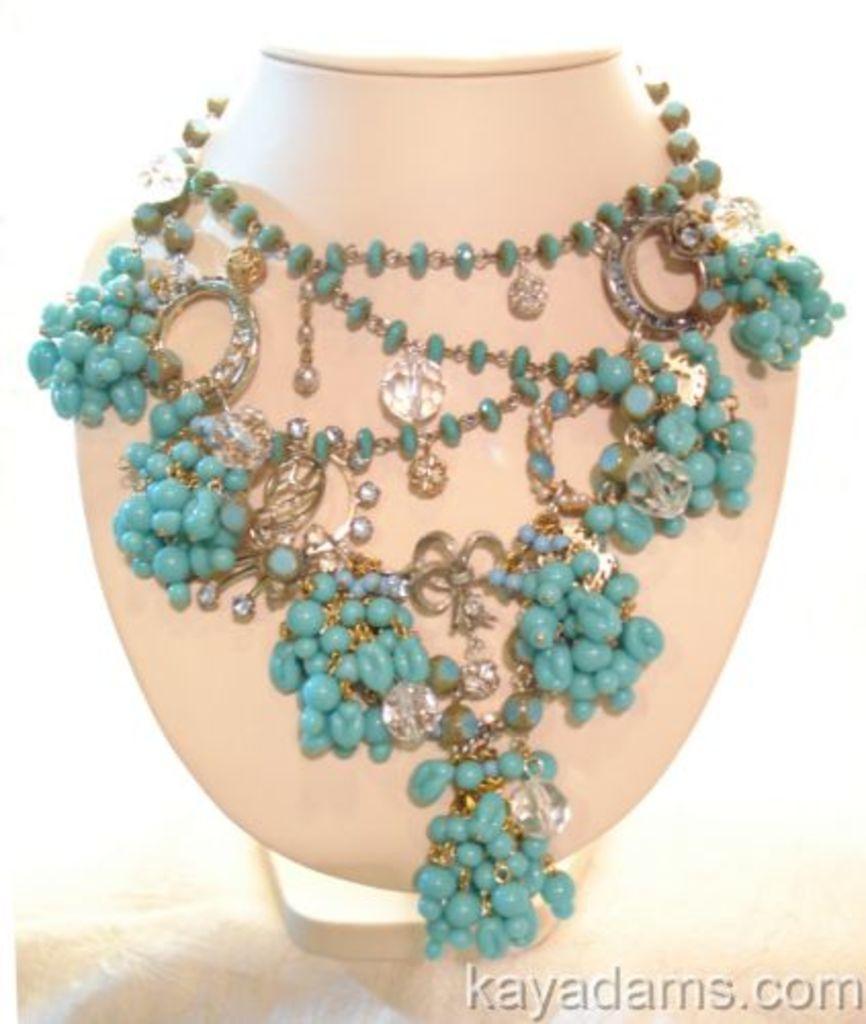In one or two sentences, can you explain what this image depicts? In this picture there is a Jewelry which is in blue color is placed on an object and there is something written in the right bottom color. 